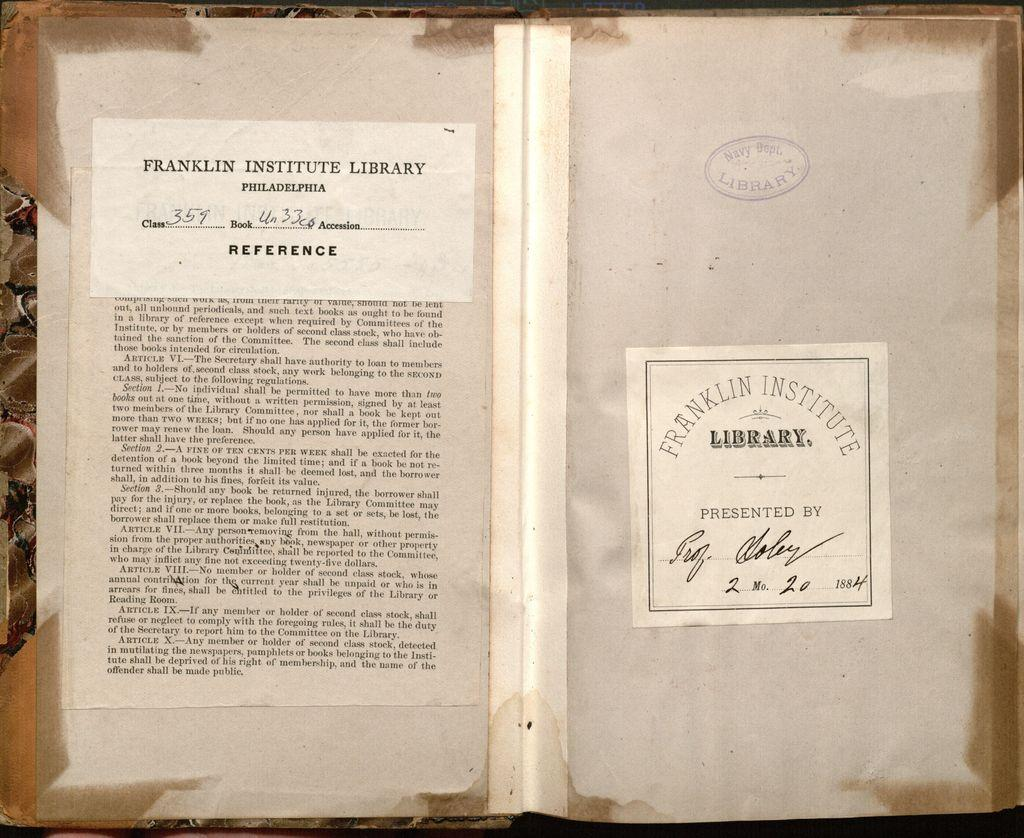Provide a one-sentence caption for the provided image. a book that appears to have been checked out from the franklin institute library. 